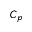<formula> <loc_0><loc_0><loc_500><loc_500>C _ { p }</formula> 